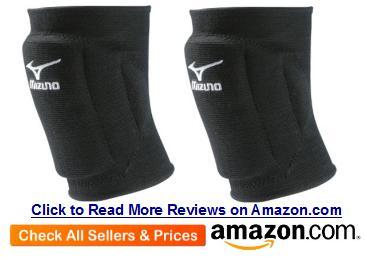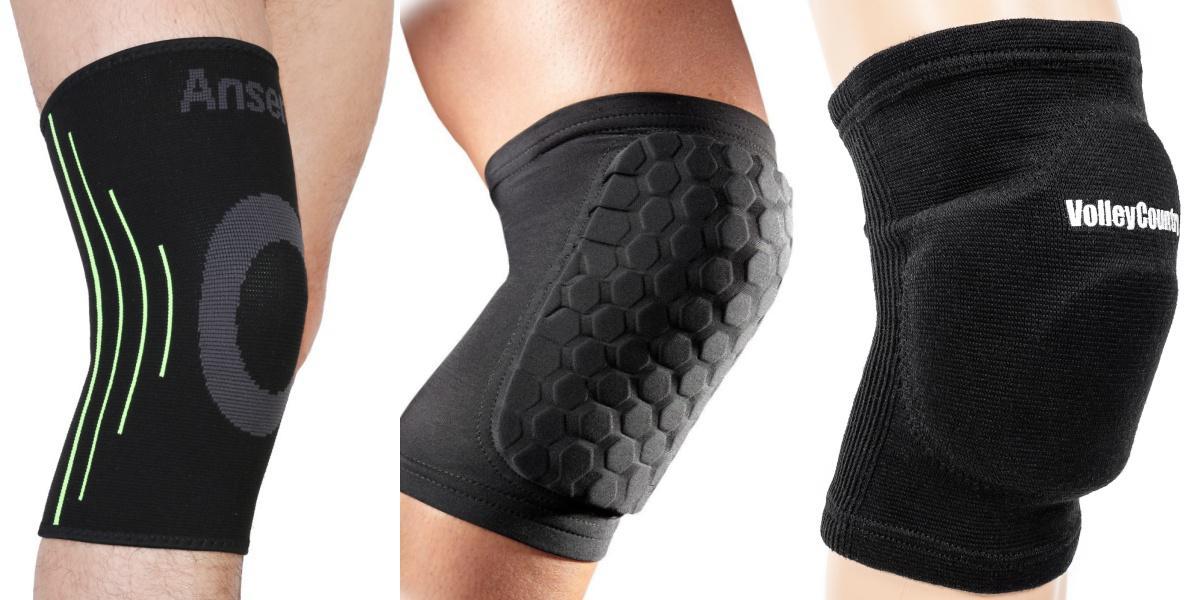The first image is the image on the left, the second image is the image on the right. Evaluate the accuracy of this statement regarding the images: "One image contains at least three legs wearing different kneepads.". Is it true? Answer yes or no. Yes. The first image is the image on the left, the second image is the image on the right. Analyze the images presented: Is the assertion "The knee braces in the left image are facing towards the left." valid? Answer yes or no. Yes. 